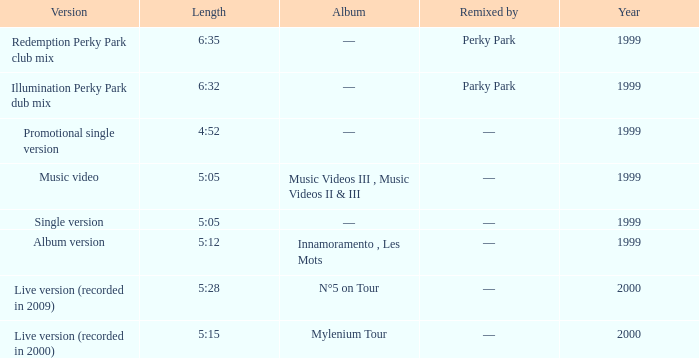What album is 5:15 long Live version (recorded in 2000). 